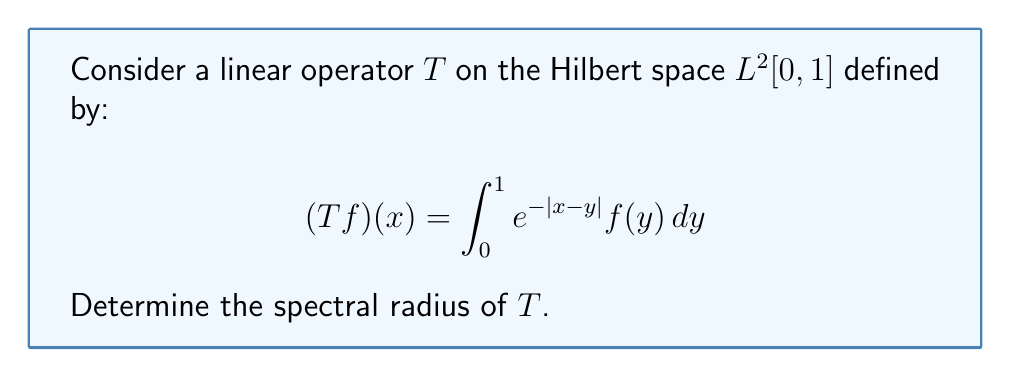Provide a solution to this math problem. To find the spectral radius of $T$, we'll follow these steps:

1) First, we need to find the operator norm of $T$. For a bounded linear operator on a Hilbert space, the spectral radius is less than or equal to the operator norm.

2) The operator norm is given by:
   $$\|T\| = \sup_{f \neq 0} \frac{\|Tf\|}{\|f\|}$$

3) We can use the Cauchy-Schwarz inequality:
   $$|(Tf)(x)| \leq \int_0^1 |e^{-|x-y|}||f(y)|dy \leq \left(\int_0^1 e^{-2|x-y|}dy\right)^{1/2}\|f\|$$

4) Calculate the integral:
   $$\int_0^1 e^{-2|x-y|}dy = \int_0^x e^{-2(x-y)}dy + \int_x^1 e^{-2(y-x)}dy = \frac{1-e^{-2x}}{2} + \frac{e^{2x}-1}{2e^{2x}} = 1$$

5) Therefore, $|(Tf)(x)| \leq \|f\|$ for all $x \in [0,1]$, which implies $\|Tf\| \leq \|f\|$.

6) This means $\|T\| \leq 1$. We can show that this bound is actually achieved for constant functions, so $\|T\| = 1$.

7) For compact self-adjoint operators (which $T$ is), the spectral radius equals the operator norm.

8) Therefore, the spectral radius of $T$ is 1.
Answer: 1 